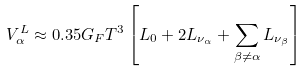<formula> <loc_0><loc_0><loc_500><loc_500>V _ { \alpha } ^ { L } \approx 0 . 3 5 G _ { F } T ^ { 3 } \left [ L _ { 0 } + 2 L _ { \nu _ { \alpha } } + \sum _ { \beta \ne \alpha } L _ { \nu _ { \beta } } \right ]</formula> 